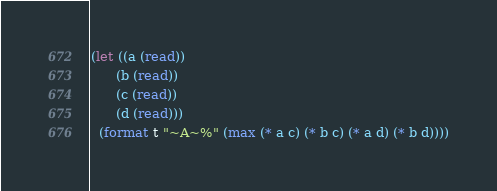Convert code to text. <code><loc_0><loc_0><loc_500><loc_500><_Lisp_>(let ((a (read))
      (b (read))
      (c (read))
      (d (read)))
  (format t "~A~%" (max (* a c) (* b c) (* a d) (* b d))))</code> 